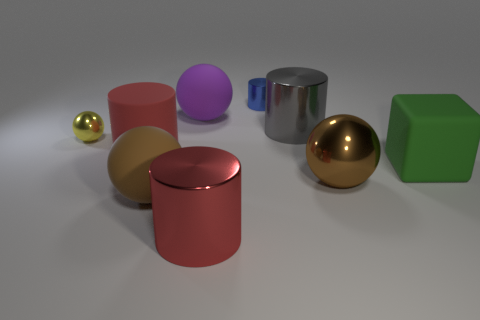Can you describe the textures of the objects shown? Certainly! The objects exhibit various textures: the two spheres and the cube are reflective and have a shiny surface, suggesting a material like polished metal or plastic. The other objects have a matte finish, which indicates that they absorb light and have a non-reflective surface typically associated with materials like rubber or matte paint. 